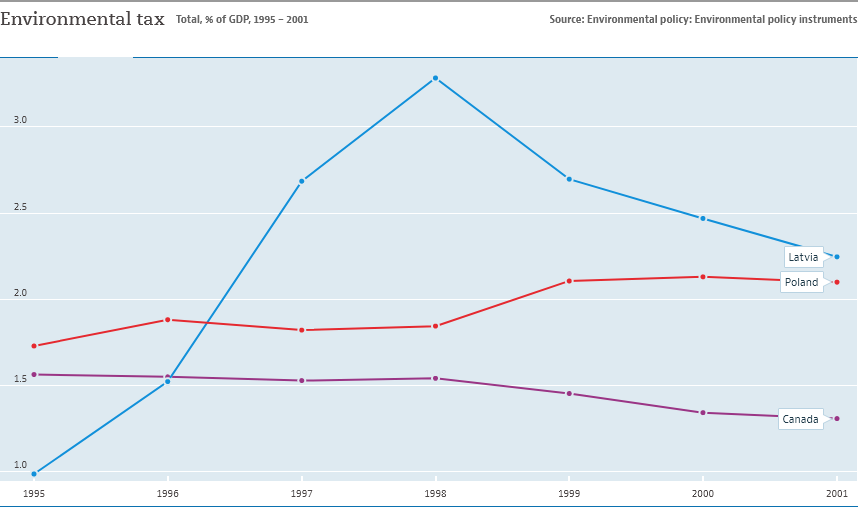Specify some key components in this picture. In the year 1998, environmental taxes were at their highest in Latvia. Latvia is represented by the blue line in the given country. 